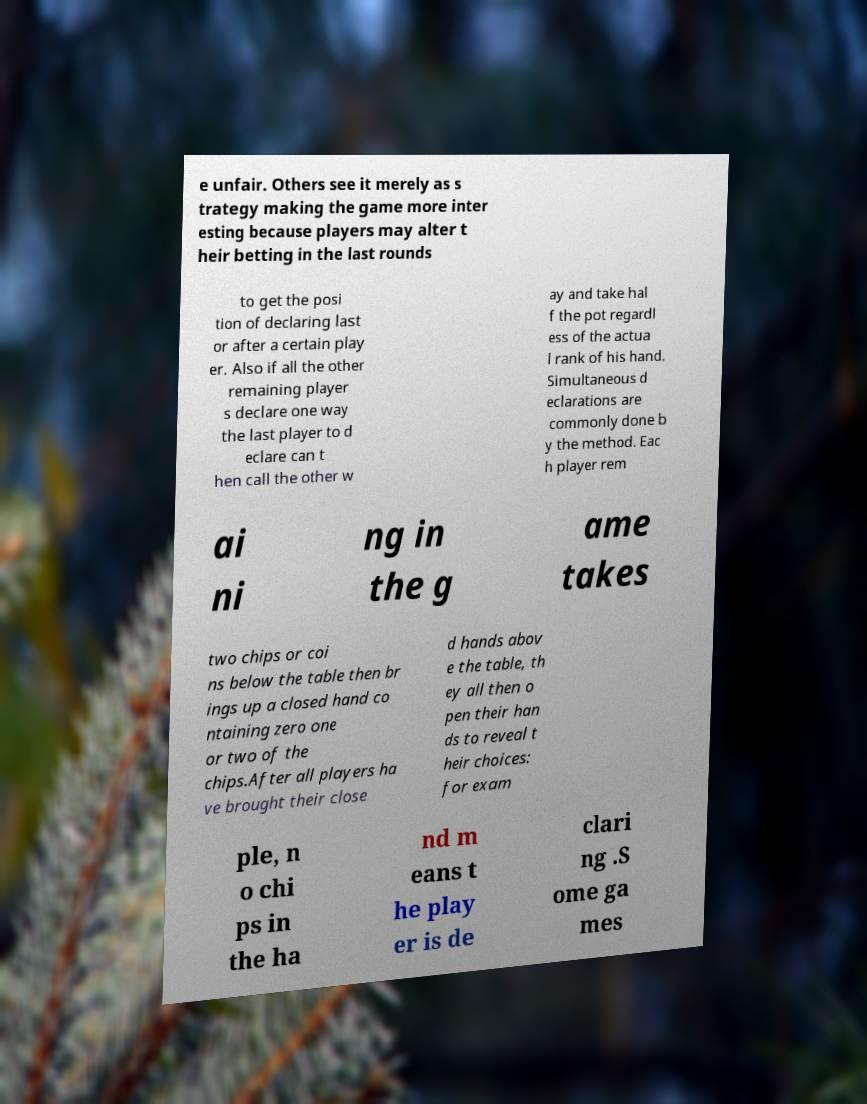Could you extract and type out the text from this image? e unfair. Others see it merely as s trategy making the game more inter esting because players may alter t heir betting in the last rounds to get the posi tion of declaring last or after a certain play er. Also if all the other remaining player s declare one way the last player to d eclare can t hen call the other w ay and take hal f the pot regardl ess of the actua l rank of his hand. Simultaneous d eclarations are commonly done b y the method. Eac h player rem ai ni ng in the g ame takes two chips or coi ns below the table then br ings up a closed hand co ntaining zero one or two of the chips.After all players ha ve brought their close d hands abov e the table, th ey all then o pen their han ds to reveal t heir choices: for exam ple, n o chi ps in the ha nd m eans t he play er is de clari ng .S ome ga mes 